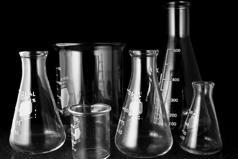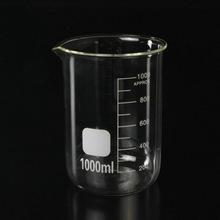The first image is the image on the left, the second image is the image on the right. Examine the images to the left and right. Is the description "The right image includes at least one cylindrical beaker made of clear glass, and the left image includes multiple glass beakers with wide bases that taper to a narrower top." accurate? Answer yes or no. Yes. The first image is the image on the left, the second image is the image on the right. For the images shown, is this caption "All of the containers are the same basic shape." true? Answer yes or no. No. 